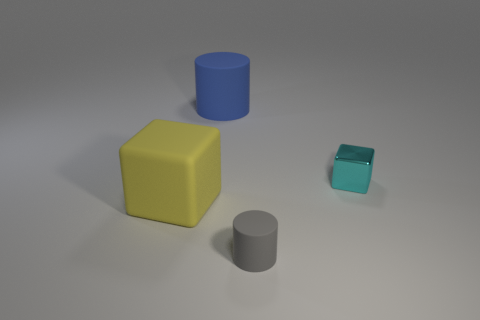Add 1 tiny cyan shiny cylinders. How many objects exist? 5 Subtract all gray cylinders. How many cylinders are left? 1 Subtract 0 cyan spheres. How many objects are left? 4 Subtract 1 cylinders. How many cylinders are left? 1 Subtract all green cubes. Subtract all gray spheres. How many cubes are left? 2 Subtract all green spheres. How many cyan cubes are left? 1 Subtract all tiny cyan things. Subtract all tiny gray metallic cubes. How many objects are left? 3 Add 4 yellow blocks. How many yellow blocks are left? 5 Add 4 big red metal objects. How many big red metal objects exist? 4 